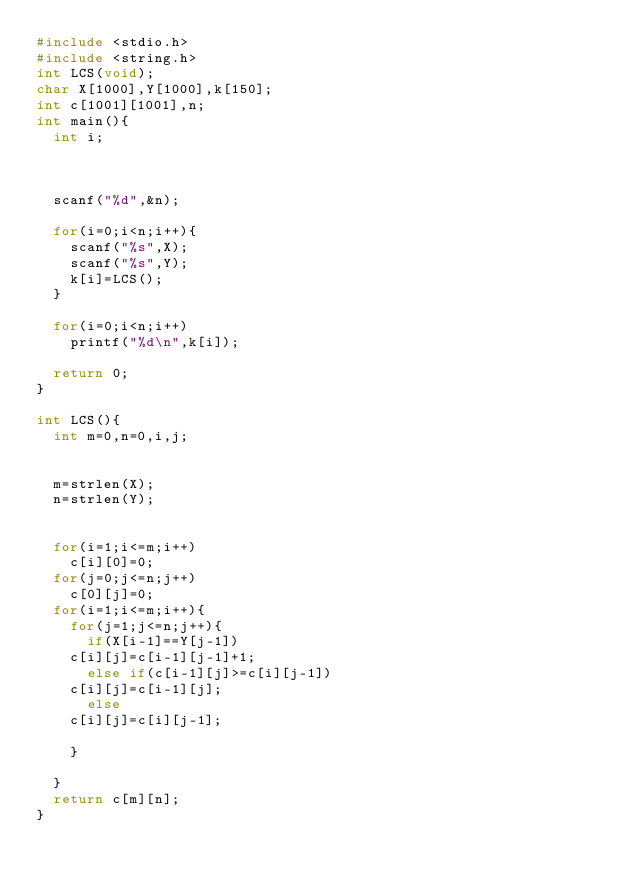<code> <loc_0><loc_0><loc_500><loc_500><_C_>#include <stdio.h>
#include <string.h>
int LCS(void);
char X[1000],Y[1000],k[150];
int c[1001][1001],n;
int main(){
  int i;

 
  
  scanf("%d",&n);

  for(i=0;i<n;i++){
    scanf("%s",X);
    scanf("%s",Y);
    k[i]=LCS();
  }

  for(i=0;i<n;i++)
    printf("%d\n",k[i]);

  return 0;
}

int LCS(){
  int m=0,n=0,i,j;

 
  m=strlen(X);
  n=strlen(Y);
  
 
  for(i=1;i<=m;i++)
    c[i][0]=0;
  for(j=0;j<=n;j++)
    c[0][j]=0;
  for(i=1;i<=m;i++){
    for(j=1;j<=n;j++){
      if(X[i-1]==Y[j-1])
	c[i][j]=c[i-1][j-1]+1;
      else if(c[i-1][j]>=c[i][j-1])
	c[i][j]=c[i-1][j];
      else
	c[i][j]=c[i][j-1];
      
    }
   
  }
  return c[m][n];
}</code> 